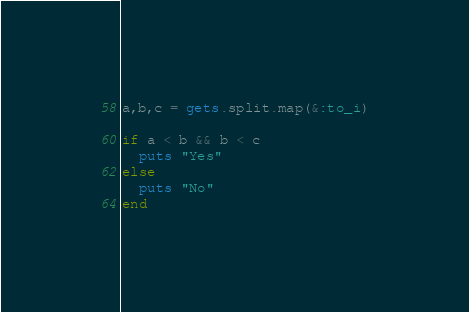Convert code to text. <code><loc_0><loc_0><loc_500><loc_500><_Ruby_>a,b,c = gets.split.map(&:to_i)

if a < b && b < c
  puts "Yes"
else
  puts "No"
end</code> 